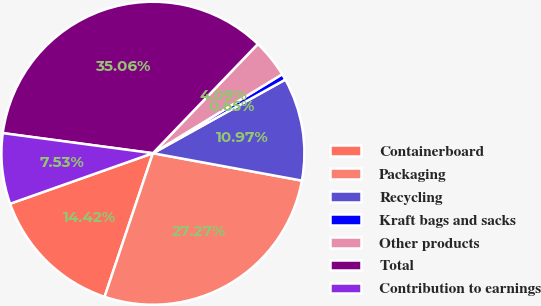Convert chart. <chart><loc_0><loc_0><loc_500><loc_500><pie_chart><fcel>Containerboard<fcel>Packaging<fcel>Recycling<fcel>Kraft bags and sacks<fcel>Other products<fcel>Total<fcel>Contribution to earnings<nl><fcel>14.42%<fcel>27.27%<fcel>10.97%<fcel>0.65%<fcel>4.09%<fcel>35.06%<fcel>7.53%<nl></chart> 